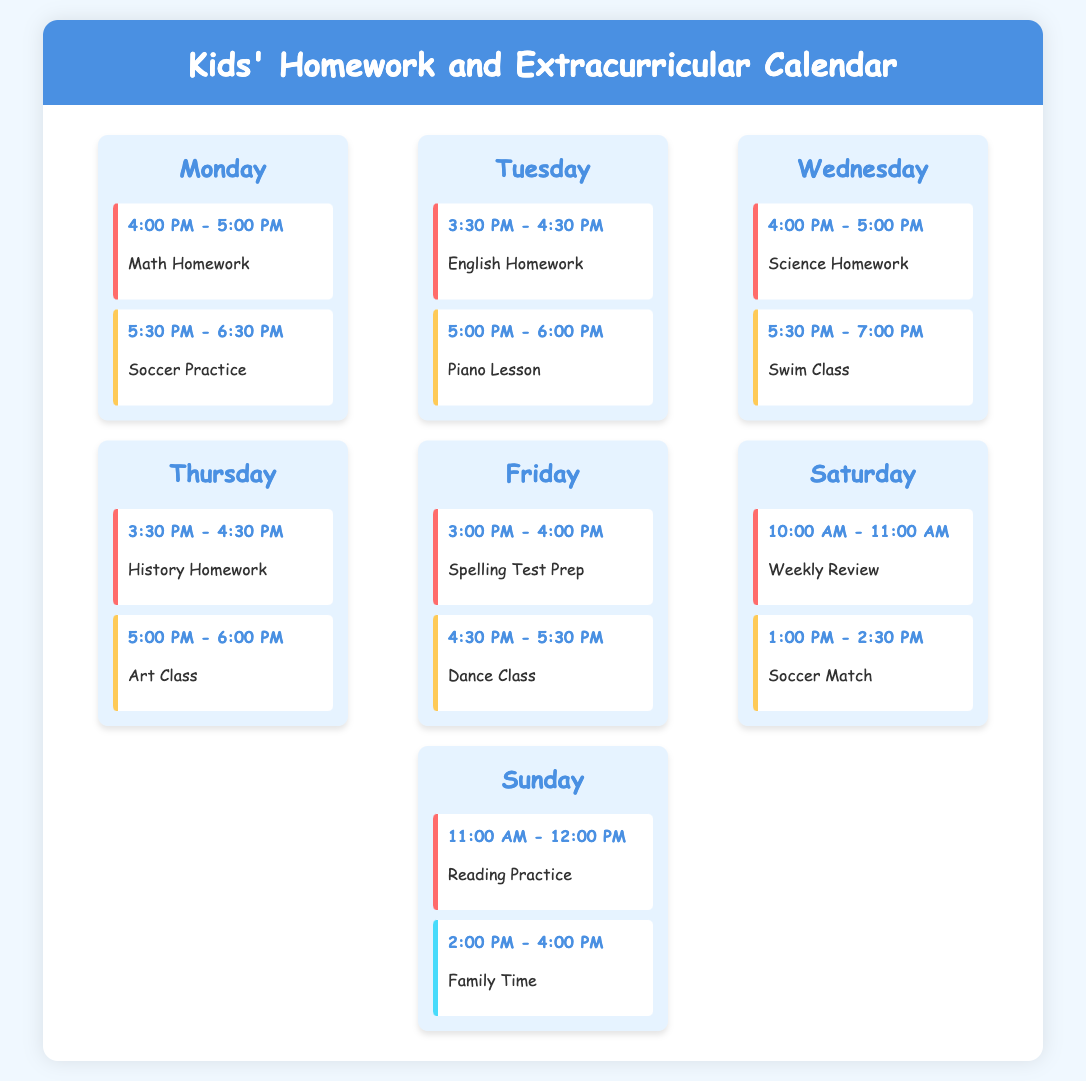What is the highest priority activity on Monday? The highest priority activity on Monday is Math Homework, scheduled from 4:00 PM to 5:00 PM.
Answer: Math Homework What time does Science Homework start on Wednesday? Science Homework starts at 4:00 PM on Wednesday.
Answer: 4:00 PM How many extracurricular activities occur on Friday? There are two extracurricular activities listed for Friday.
Answer: 2 What is the duration of the Reading Practice activity on Sunday? Reading Practice lasts for 1 hour, from 11:00 AM to 12:00 PM.
Answer: 1 hour Which extracurricular activity has the highest priority on Tuesday? The highest priority extracurricular activity on Tuesday is Piano Lesson.
Answer: Piano Lesson On which day is the Weekly Review scheduled? The Weekly Review is scheduled for Saturday.
Answer: Saturday What is the priority level of Family Time on Sunday? Family Time has a low priority level on Sunday.
Answer: Low What time does Soccer Practice start on Monday? Soccer Practice starts at 5:30 PM on Monday.
Answer: 5:30 PM How many activities are scheduled for Thursday? There are two activities scheduled for Thursday.
Answer: 2 